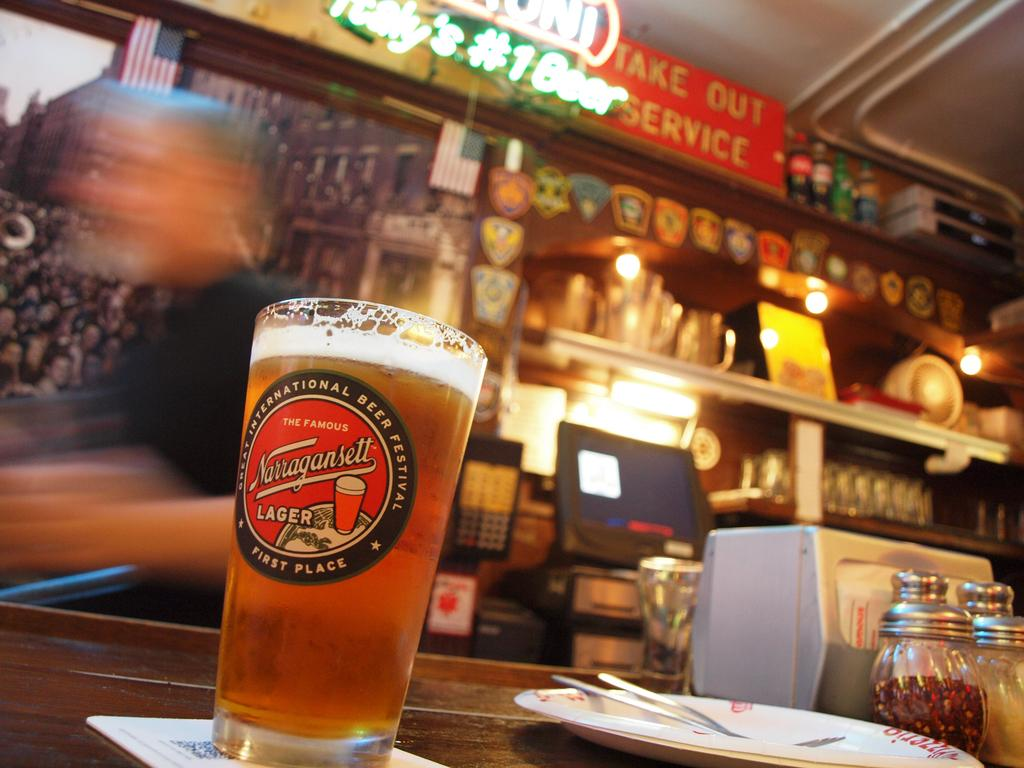<image>
Describe the image concisely. a beer glass from Narragansett is full sitting on the bar 